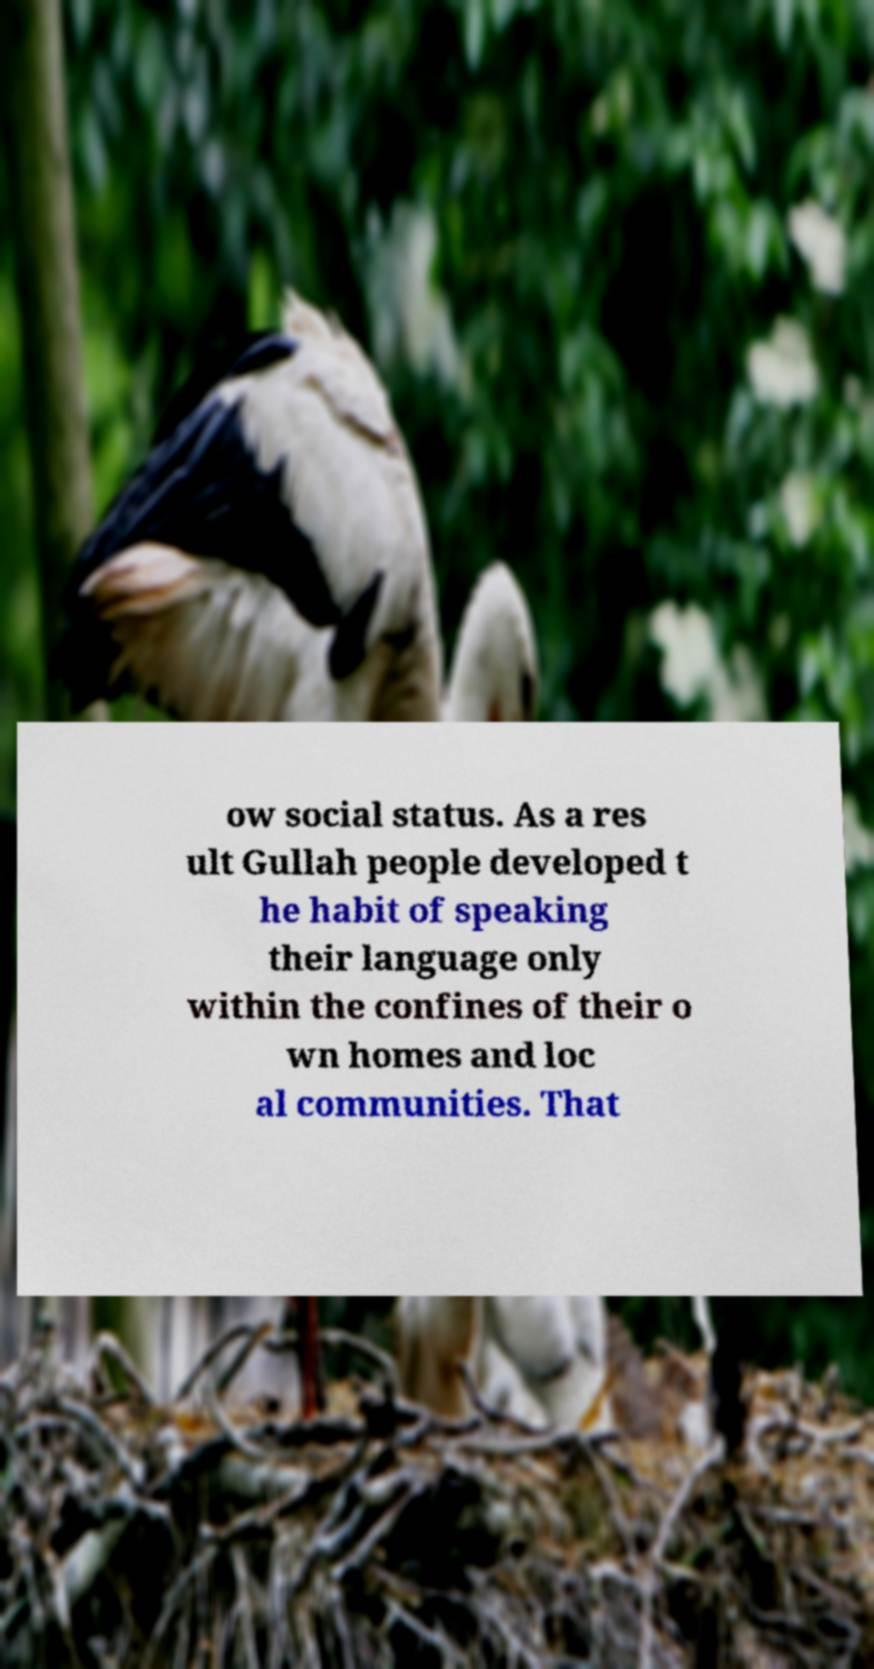Please read and relay the text visible in this image. What does it say? ow social status. As a res ult Gullah people developed t he habit of speaking their language only within the confines of their o wn homes and loc al communities. That 